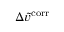<formula> <loc_0><loc_0><loc_500><loc_500>\Delta \tilde { v } ^ { c o r r }</formula> 